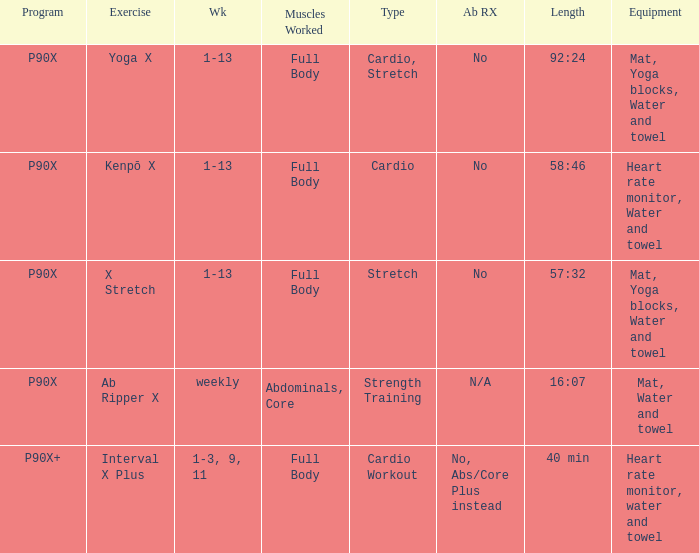What is the exercise when the equipment is heart rate monitor, water and towel? Kenpō X, Interval X Plus. 